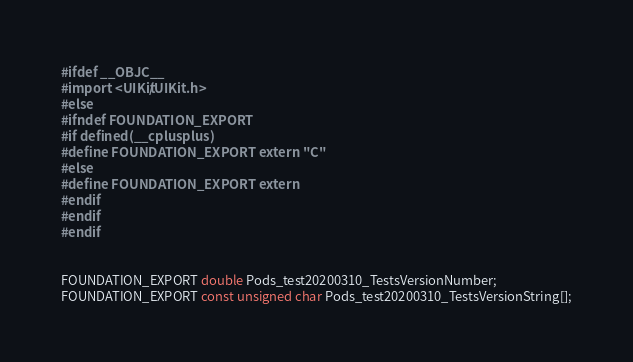Convert code to text. <code><loc_0><loc_0><loc_500><loc_500><_C_>#ifdef __OBJC__
#import <UIKit/UIKit.h>
#else
#ifndef FOUNDATION_EXPORT
#if defined(__cplusplus)
#define FOUNDATION_EXPORT extern "C"
#else
#define FOUNDATION_EXPORT extern
#endif
#endif
#endif


FOUNDATION_EXPORT double Pods_test20200310_TestsVersionNumber;
FOUNDATION_EXPORT const unsigned char Pods_test20200310_TestsVersionString[];

</code> 